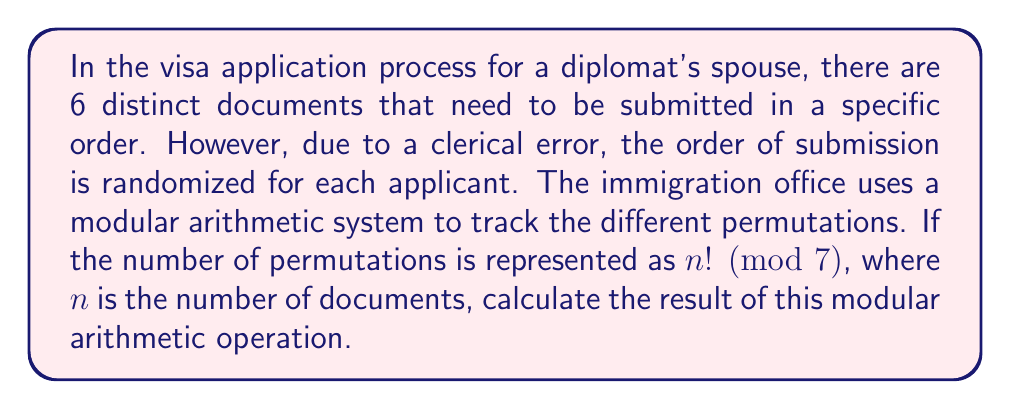Help me with this question. To solve this problem, we need to follow these steps:

1) First, we need to calculate the number of permutations. With 6 distinct documents, the number of permutations is 6!.

2) Calculate 6!:
   $6! = 6 \times 5 \times 4 \times 3 \times 2 \times 1 = 720$

3) Now, we need to calculate $720 \pmod{7}$. This means we need to find the remainder when 720 is divided by 7.

4) We can do this by dividing 720 by 7:
   $720 \div 7 = 102$ remainder $6$

5) Therefore, $720 \pmod{7} = 6$

This result means that in the modular arithmetic system used by the immigration office, the number of permutations of the 6 documents is represented by 6.
Answer: $6! \pmod{7} = 6$ 